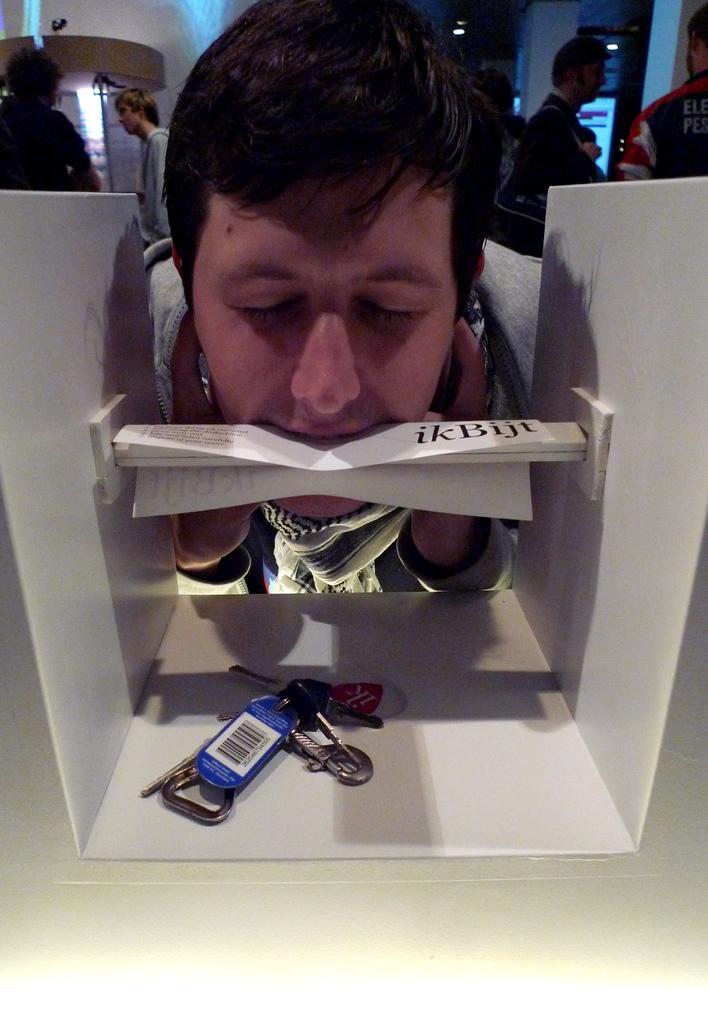Can you describe this image briefly? In this image we can see there is a person placed his head in the box and removing the paper which is attached in inside the box with the help of his mouth. In the box there is a keychain. In the background there are some people standing. 